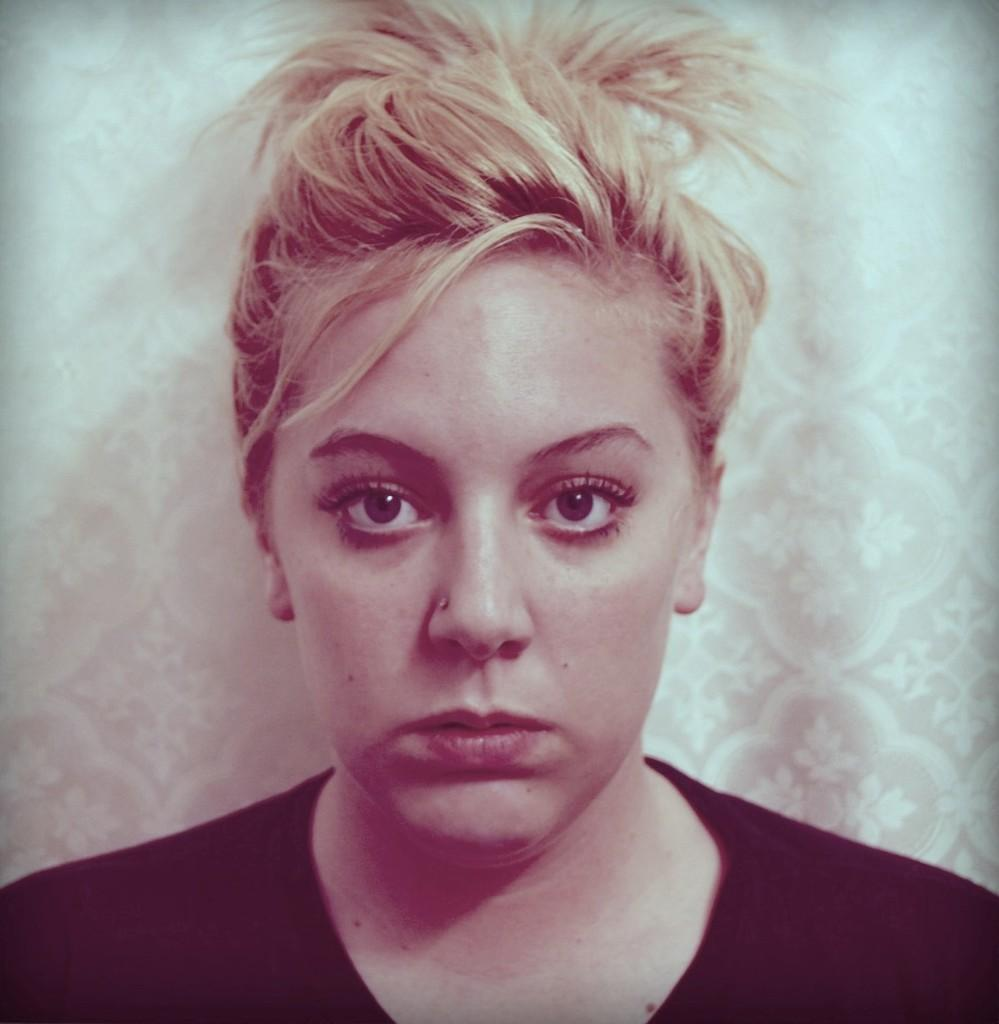Who is present in the image? There is a woman in the image. What is the woman wearing? The woman is wearing a black t-shirt. What can be seen in the background of the image? There is a wall visible in the background of the image. What type of milk is the woman holding in the image? There is no milk present in the image; the woman is not holding anything. 